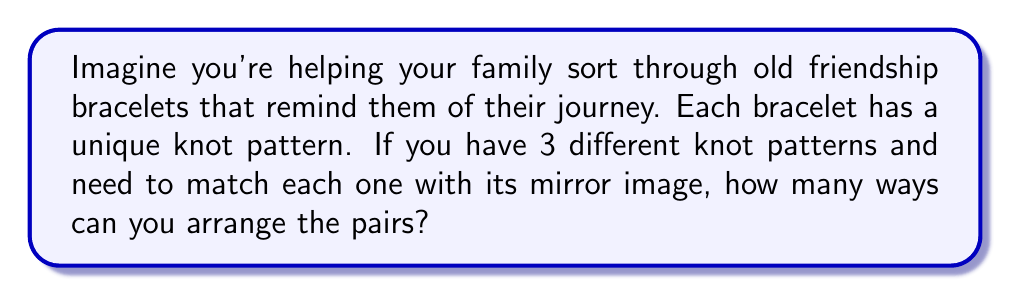Give your solution to this math problem. Let's approach this step-by-step:

1) First, we need to understand what we're dealing with:
   - We have 3 original knot patterns
   - Each pattern has a mirror image
   - We need to pair each original with its mirror image

2) This is a matching problem. We're not choosing which ones to match (as each must be matched with its mirror), but rather in how many ways we can arrange these pairs.

3) For the first pair, we have 3 choices of which original pattern to place.

4) After placing the first pair, we have 2 choices left for the second pair.

5) For the last pair, we only have 1 choice left, as it's the only remaining pair.

6) Using the multiplication principle, we can calculate the total number of ways to arrange these pairs:

   $$ 3 \times 2 \times 1 = 6 $$

7) This is also known as 3 factorial, written as 3!:

   $$ 3! = 3 \times 2 \times 1 = 6 $$

Therefore, there are 6 ways to arrange the pairs of knot patterns with their mirror images.
Answer: 6 